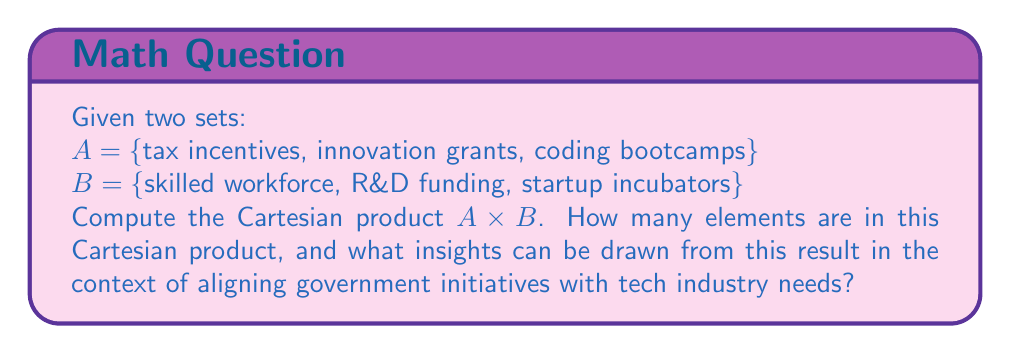Solve this math problem. To solve this problem, we need to follow these steps:

1) Recall the definition of Cartesian product:
   The Cartesian product of two sets A and B, denoted $A \times B$, is the set of all ordered pairs (a, b) where a ∈ A and b ∈ B.

2) List all possible ordered pairs:
   $A \times B = \{$ (tax incentives, skilled workforce), (tax incentives, R&D funding), (tax incentives, startup incubators),
                   (innovation grants, skilled workforce), (innovation grants, R&D funding), (innovation grants, startup incubators),
                   (coding bootcamps, skilled workforce), (coding bootcamps, R&D funding), (coding bootcamps, startup incubators) $\}$

3) Count the number of elements:
   The number of elements in $A \times B$ is equal to $|A| \times |B|$, where $|A|$ and $|B|$ are the number of elements in sets A and B respectively.
   $|A| = 3$, $|B| = 3$
   Therefore, $|A \times B| = 3 \times 3 = 9$

4) Interpret the result:
   Each pair in the Cartesian product represents a potential alignment between a government initiative and a tech industry need. For example, (tax incentives, startup incubators) suggests that tax incentives could be used to support startup incubators.

   The Cartesian product provides a comprehensive view of all possible combinations, allowing policymakers to consider each potential pairing and its implications. This can be useful for:
   a) Identifying synergies between initiatives and needs
   b) Prioritizing policies that address multiple needs
   c) Discovering innovative ways to support the tech industry
   d) Ensuring a balanced approach that covers all aspects of tech industry support

   The number of elements (9) indicates the complexity of the policy landscape and the need for a multifaceted approach to supporting the tech industry.
Answer: The Cartesian product $A \times B$ contains 9 elements. This result highlights the diverse range of potential policy alignments between government initiatives and tech industry needs, emphasizing the importance of a comprehensive and strategic approach to tech education and entrepreneurship support. 